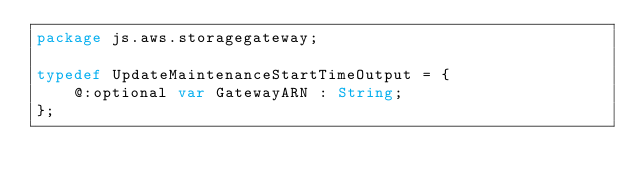<code> <loc_0><loc_0><loc_500><loc_500><_Haxe_>package js.aws.storagegateway;

typedef UpdateMaintenanceStartTimeOutput = {
    @:optional var GatewayARN : String;
};
</code> 